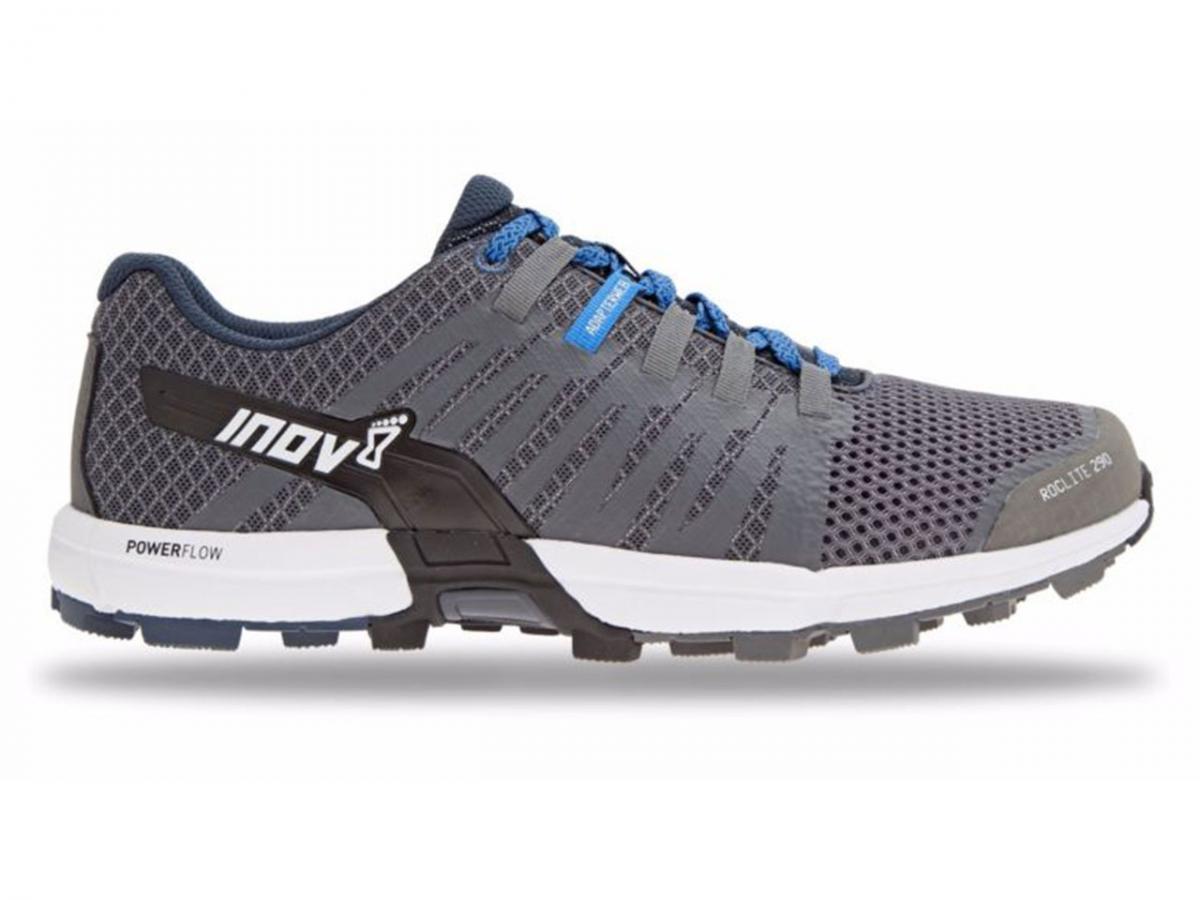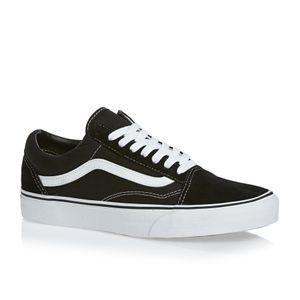The first image is the image on the left, the second image is the image on the right. Analyze the images presented: Is the assertion "Left and right images each contain a single shoe with an athletic tread sole, one shoe has a zig-zag design element, and the shoe on the right has a loop at the heel." valid? Answer yes or no. No. The first image is the image on the left, the second image is the image on the right. For the images shown, is this caption "The toes of all the shoes point to the right side." true? Answer yes or no. Yes. 